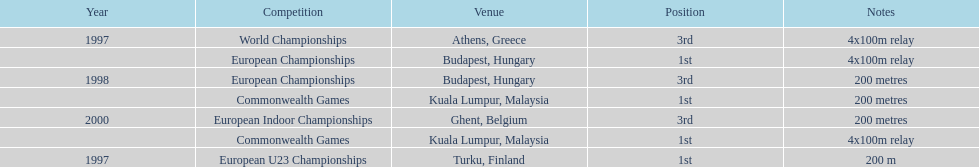How frequently was golding in second position? 0. 